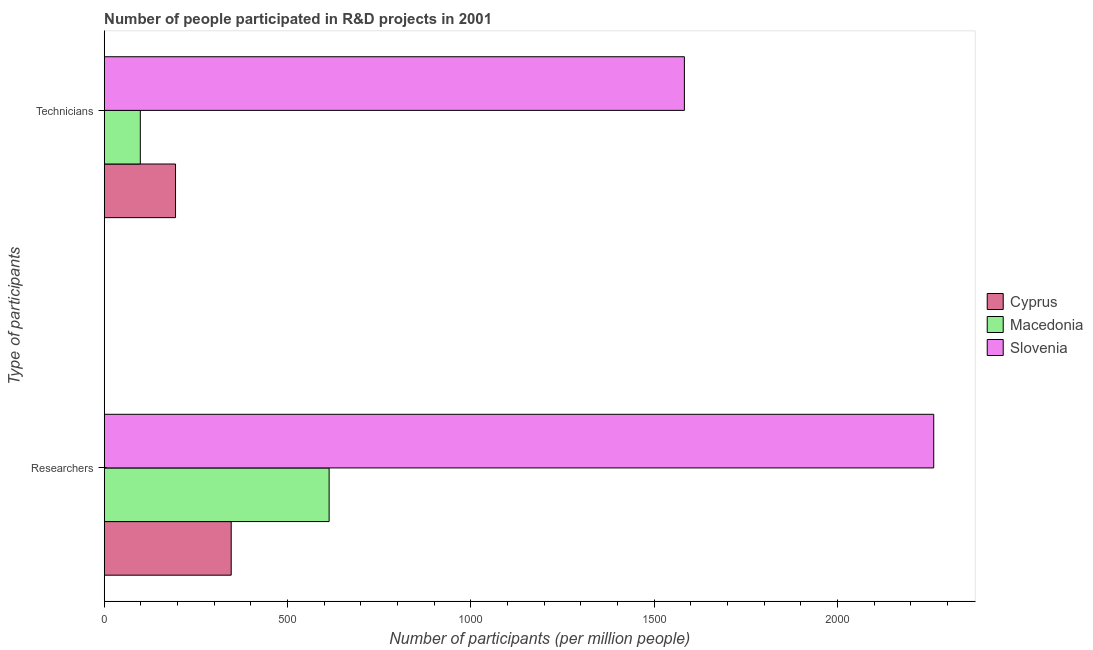How many different coloured bars are there?
Your answer should be compact. 3. How many groups of bars are there?
Your response must be concise. 2. Are the number of bars per tick equal to the number of legend labels?
Provide a succinct answer. Yes. Are the number of bars on each tick of the Y-axis equal?
Your answer should be compact. Yes. How many bars are there on the 1st tick from the bottom?
Give a very brief answer. 3. What is the label of the 1st group of bars from the top?
Ensure brevity in your answer.  Technicians. What is the number of researchers in Cyprus?
Provide a succinct answer. 346.34. Across all countries, what is the maximum number of technicians?
Your response must be concise. 1582.27. Across all countries, what is the minimum number of technicians?
Your response must be concise. 98.44. In which country was the number of technicians maximum?
Your answer should be compact. Slovenia. In which country was the number of technicians minimum?
Your answer should be very brief. Macedonia. What is the total number of technicians in the graph?
Provide a succinct answer. 1875.2. What is the difference between the number of technicians in Cyprus and that in Macedonia?
Offer a terse response. 96.05. What is the difference between the number of researchers in Cyprus and the number of technicians in Macedonia?
Make the answer very short. 247.9. What is the average number of technicians per country?
Your answer should be compact. 625.07. What is the difference between the number of technicians and number of researchers in Macedonia?
Your answer should be very brief. -514.94. What is the ratio of the number of technicians in Macedonia to that in Slovenia?
Provide a short and direct response. 0.06. Is the number of technicians in Macedonia less than that in Slovenia?
Provide a short and direct response. Yes. In how many countries, is the number of researchers greater than the average number of researchers taken over all countries?
Give a very brief answer. 1. What does the 2nd bar from the top in Technicians represents?
Offer a terse response. Macedonia. What does the 2nd bar from the bottom in Technicians represents?
Your response must be concise. Macedonia. How many bars are there?
Your answer should be very brief. 6. How many countries are there in the graph?
Provide a succinct answer. 3. What is the difference between two consecutive major ticks on the X-axis?
Keep it short and to the point. 500. Are the values on the major ticks of X-axis written in scientific E-notation?
Ensure brevity in your answer.  No. Does the graph contain any zero values?
Offer a terse response. No. How many legend labels are there?
Offer a terse response. 3. What is the title of the graph?
Ensure brevity in your answer.  Number of people participated in R&D projects in 2001. Does "Samoa" appear as one of the legend labels in the graph?
Keep it short and to the point. No. What is the label or title of the X-axis?
Provide a short and direct response. Number of participants (per million people). What is the label or title of the Y-axis?
Give a very brief answer. Type of participants. What is the Number of participants (per million people) in Cyprus in Researchers?
Your response must be concise. 346.34. What is the Number of participants (per million people) in Macedonia in Researchers?
Give a very brief answer. 613.38. What is the Number of participants (per million people) of Slovenia in Researchers?
Make the answer very short. 2262.25. What is the Number of participants (per million people) of Cyprus in Technicians?
Offer a terse response. 194.49. What is the Number of participants (per million people) in Macedonia in Technicians?
Give a very brief answer. 98.44. What is the Number of participants (per million people) of Slovenia in Technicians?
Ensure brevity in your answer.  1582.27. Across all Type of participants, what is the maximum Number of participants (per million people) of Cyprus?
Keep it short and to the point. 346.34. Across all Type of participants, what is the maximum Number of participants (per million people) in Macedonia?
Your answer should be compact. 613.38. Across all Type of participants, what is the maximum Number of participants (per million people) in Slovenia?
Your response must be concise. 2262.25. Across all Type of participants, what is the minimum Number of participants (per million people) of Cyprus?
Your answer should be compact. 194.49. Across all Type of participants, what is the minimum Number of participants (per million people) of Macedonia?
Offer a terse response. 98.44. Across all Type of participants, what is the minimum Number of participants (per million people) in Slovenia?
Your answer should be compact. 1582.27. What is the total Number of participants (per million people) in Cyprus in the graph?
Offer a very short reply. 540.83. What is the total Number of participants (per million people) of Macedonia in the graph?
Your response must be concise. 711.82. What is the total Number of participants (per million people) in Slovenia in the graph?
Keep it short and to the point. 3844.52. What is the difference between the Number of participants (per million people) in Cyprus in Researchers and that in Technicians?
Your response must be concise. 151.85. What is the difference between the Number of participants (per million people) in Macedonia in Researchers and that in Technicians?
Provide a succinct answer. 514.94. What is the difference between the Number of participants (per million people) of Slovenia in Researchers and that in Technicians?
Your response must be concise. 679.98. What is the difference between the Number of participants (per million people) of Cyprus in Researchers and the Number of participants (per million people) of Macedonia in Technicians?
Provide a short and direct response. 247.9. What is the difference between the Number of participants (per million people) in Cyprus in Researchers and the Number of participants (per million people) in Slovenia in Technicians?
Ensure brevity in your answer.  -1235.93. What is the difference between the Number of participants (per million people) of Macedonia in Researchers and the Number of participants (per million people) of Slovenia in Technicians?
Offer a very short reply. -968.89. What is the average Number of participants (per million people) in Cyprus per Type of participants?
Offer a very short reply. 270.42. What is the average Number of participants (per million people) of Macedonia per Type of participants?
Your answer should be compact. 355.91. What is the average Number of participants (per million people) in Slovenia per Type of participants?
Ensure brevity in your answer.  1922.26. What is the difference between the Number of participants (per million people) of Cyprus and Number of participants (per million people) of Macedonia in Researchers?
Provide a succinct answer. -267.04. What is the difference between the Number of participants (per million people) of Cyprus and Number of participants (per million people) of Slovenia in Researchers?
Your response must be concise. -1915.91. What is the difference between the Number of participants (per million people) in Macedonia and Number of participants (per million people) in Slovenia in Researchers?
Give a very brief answer. -1648.87. What is the difference between the Number of participants (per million people) in Cyprus and Number of participants (per million people) in Macedonia in Technicians?
Your response must be concise. 96.05. What is the difference between the Number of participants (per million people) of Cyprus and Number of participants (per million people) of Slovenia in Technicians?
Offer a terse response. -1387.78. What is the difference between the Number of participants (per million people) in Macedonia and Number of participants (per million people) in Slovenia in Technicians?
Your answer should be compact. -1483.83. What is the ratio of the Number of participants (per million people) in Cyprus in Researchers to that in Technicians?
Your response must be concise. 1.78. What is the ratio of the Number of participants (per million people) of Macedonia in Researchers to that in Technicians?
Your response must be concise. 6.23. What is the ratio of the Number of participants (per million people) in Slovenia in Researchers to that in Technicians?
Offer a very short reply. 1.43. What is the difference between the highest and the second highest Number of participants (per million people) in Cyprus?
Ensure brevity in your answer.  151.85. What is the difference between the highest and the second highest Number of participants (per million people) in Macedonia?
Give a very brief answer. 514.94. What is the difference between the highest and the second highest Number of participants (per million people) in Slovenia?
Make the answer very short. 679.98. What is the difference between the highest and the lowest Number of participants (per million people) in Cyprus?
Offer a very short reply. 151.85. What is the difference between the highest and the lowest Number of participants (per million people) in Macedonia?
Offer a terse response. 514.94. What is the difference between the highest and the lowest Number of participants (per million people) of Slovenia?
Your answer should be compact. 679.98. 